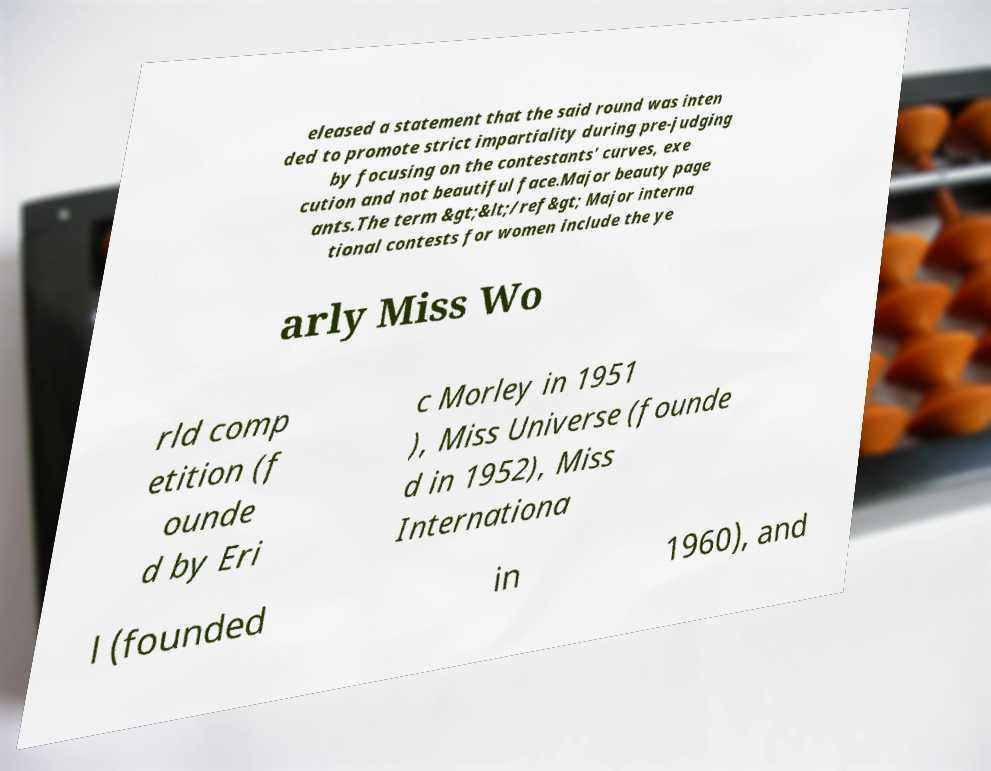Could you assist in decoding the text presented in this image and type it out clearly? eleased a statement that the said round was inten ded to promote strict impartiality during pre-judging by focusing on the contestants' curves, exe cution and not beautiful face.Major beauty page ants.The term &gt;&lt;/ref&gt; Major interna tional contests for women include the ye arly Miss Wo rld comp etition (f ounde d by Eri c Morley in 1951 ), Miss Universe (founde d in 1952), Miss Internationa l (founded in 1960), and 